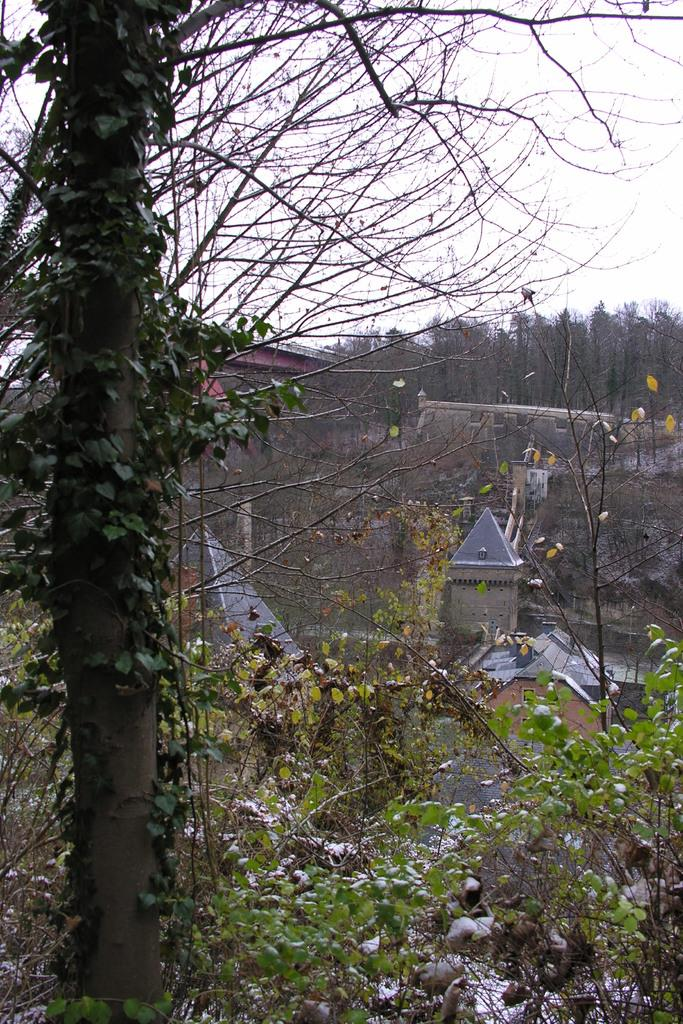What type of natural elements can be seen in the image? There are many trees and plants in the image. What type of man-made structures are visible in the image? There are buildings in the image. What can be seen in the background of the image? Water is visible in the background of the image. How many dogs are playing in the hole in the image? There are no dogs or holes present in the image. 